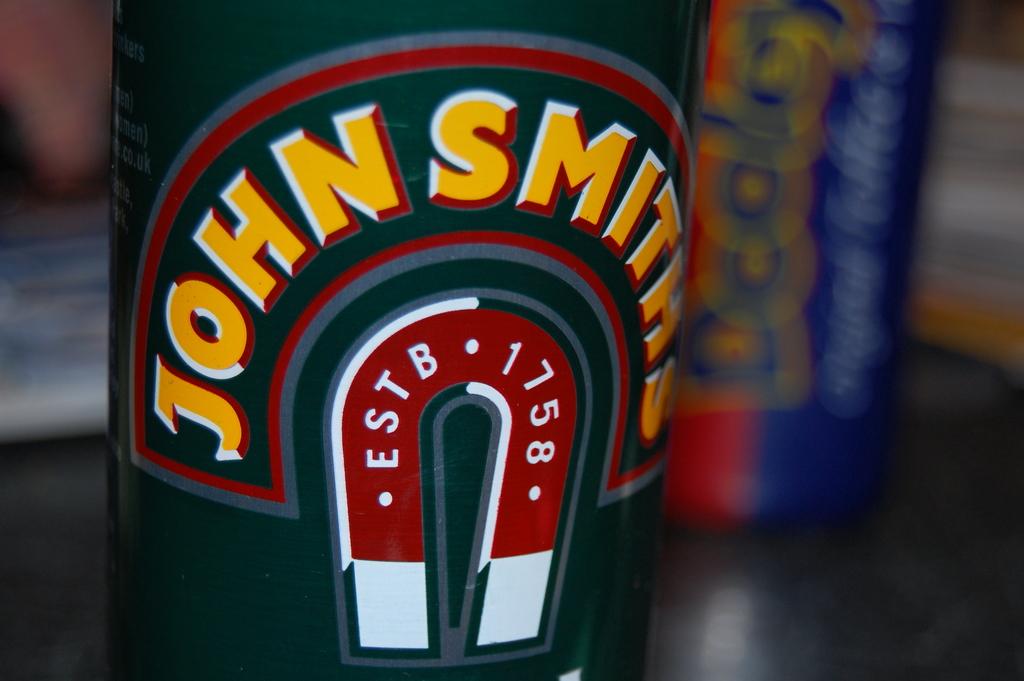When was john smith established?
Offer a terse response. 1758. Who was established in 1758?
Your answer should be compact. John smiths. 